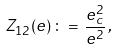<formula> <loc_0><loc_0><loc_500><loc_500>Z _ { 1 2 } ( e ) \, \colon = \, \frac { e _ { c } ^ { 2 } } { e ^ { 2 } } \, ,</formula> 